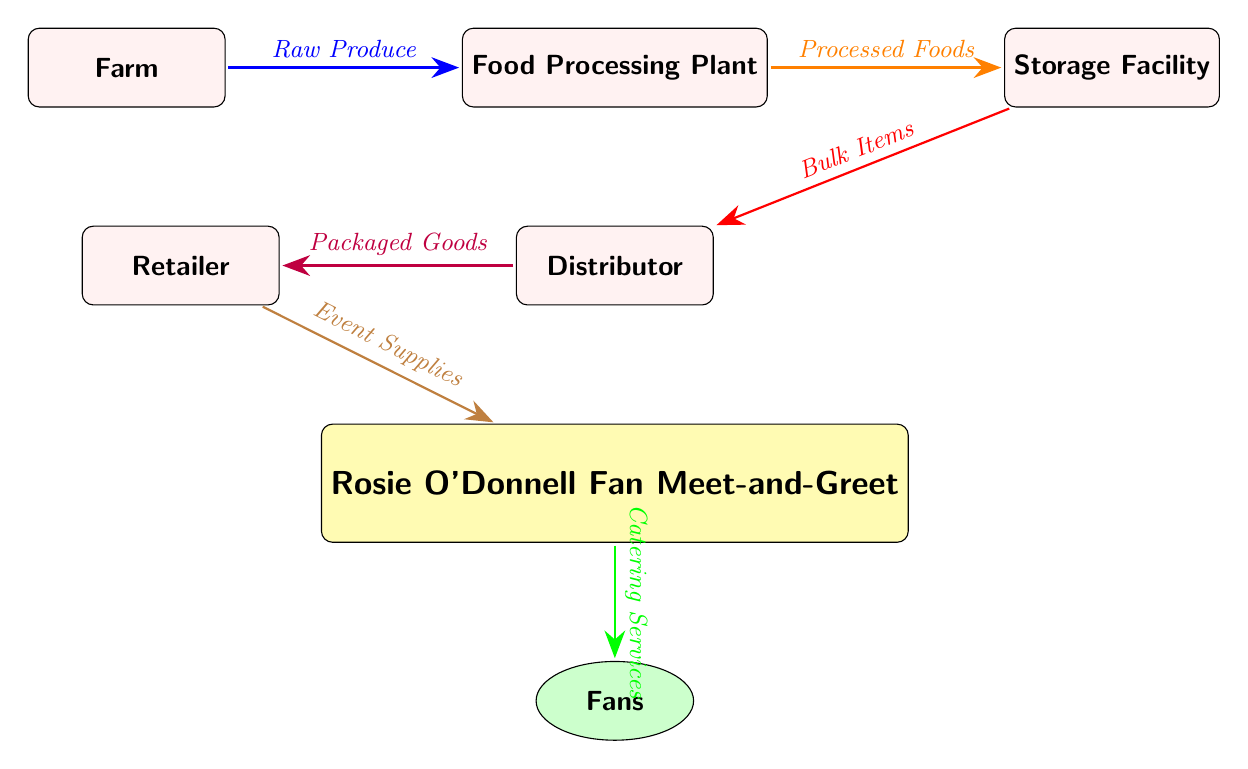What is the first node in the food supply chain? The diagram begins with the "Farm" node, which is the starting point of the food supply chain. It's positioned at the top left of the diagram, indicating the origin of raw produce.
Answer: Farm How many nodes are in the diagram? The diagram displays six nodes, which can be counted visually: Farm, Food Processing Plant, Storage Facility, Distributor, Retailer, and Rosie O'Donnell Fan Meet-and-Greet.
Answer: 6 What type of items are moved from the processing node to the storage node? The flow from the "Food Processing Plant" to the "Storage Facility" is labeled as "Processed Foods," indicating this is the type of items being transferred.
Answer: Processed Foods Which node directly supplies the event in the diagram? The "Retailer" node provides "Event Supplies" directly to the "Rosie O'Donnell Fan Meet-and-Greet" node, as indicated by the arrow leading from the Retailer to the Event.
Answer: Retailer What is the final output of the food supply chain as represented in this diagram? The final outcome of the food supply chain is "Catering Services," which is shown as the last connection going from the "Rosie O'Donnell Fan Meet-and-Greet" to the "Fans" node.
Answer: Catering Services What is the relationship between the storage and distributor nodes? The storage node sends "Bulk Items" to the distributor node, which means that the distributor receives these bulk items for further processing in the chain.
Answer: Bulk Items What color represents the event node in the diagram? The event node is filled with yellow, which visually signifies it as a distinct part of the supply chain specifically related to the celebrity event.
Answer: Yellow How does food transition from the farm to fans? The food transitions from the farm to the fans by moving through several nodes: first from the farm to the processing plant, then to the storage facility, followed by the distributor, retailer, and finally to the event where it reaches the fans as catering services.
Answer: Farm → Processing Plant → Storage Facility → Distributor → Retailer → Event → Fans 